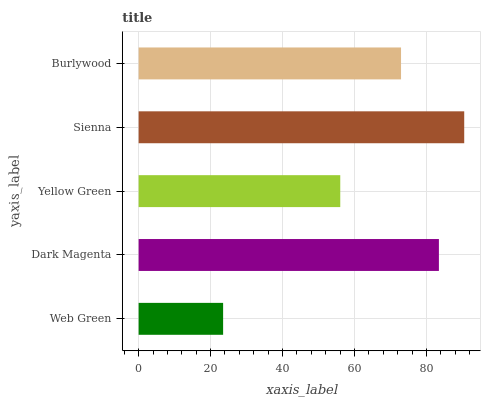Is Web Green the minimum?
Answer yes or no. Yes. Is Sienna the maximum?
Answer yes or no. Yes. Is Dark Magenta the minimum?
Answer yes or no. No. Is Dark Magenta the maximum?
Answer yes or no. No. Is Dark Magenta greater than Web Green?
Answer yes or no. Yes. Is Web Green less than Dark Magenta?
Answer yes or no. Yes. Is Web Green greater than Dark Magenta?
Answer yes or no. No. Is Dark Magenta less than Web Green?
Answer yes or no. No. Is Burlywood the high median?
Answer yes or no. Yes. Is Burlywood the low median?
Answer yes or no. Yes. Is Sienna the high median?
Answer yes or no. No. Is Yellow Green the low median?
Answer yes or no. No. 